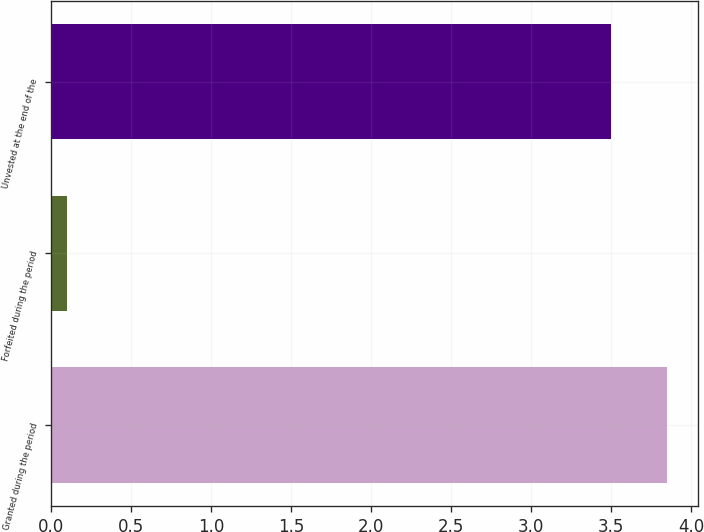<chart> <loc_0><loc_0><loc_500><loc_500><bar_chart><fcel>Granted during the period<fcel>Forfeited during the period<fcel>Unvested at the end of the<nl><fcel>3.85<fcel>0.1<fcel>3.5<nl></chart> 